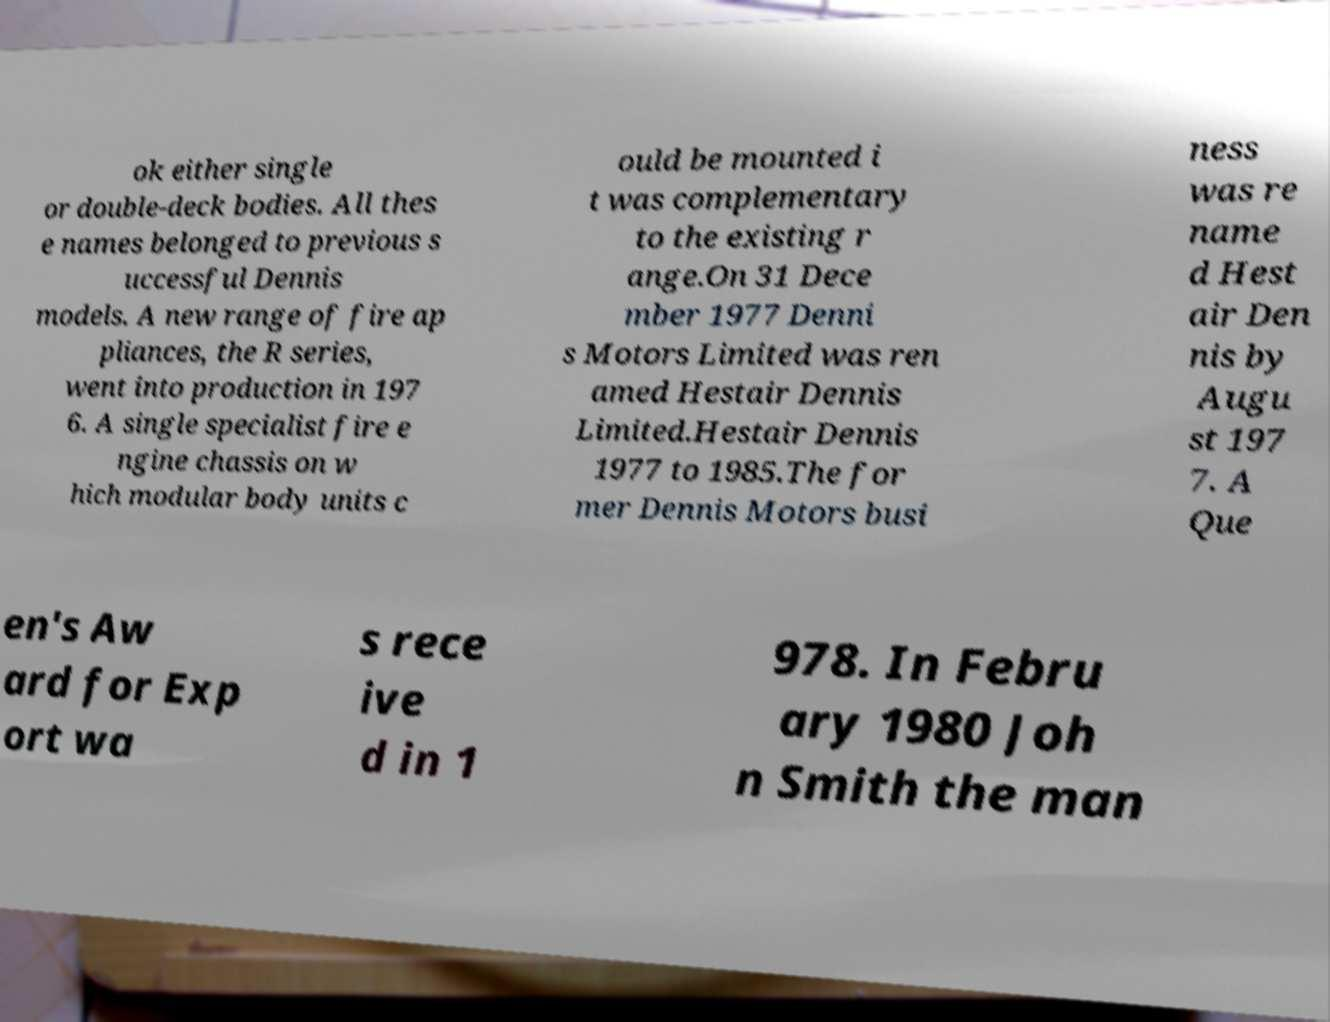Could you extract and type out the text from this image? ok either single or double-deck bodies. All thes e names belonged to previous s uccessful Dennis models. A new range of fire ap pliances, the R series, went into production in 197 6. A single specialist fire e ngine chassis on w hich modular body units c ould be mounted i t was complementary to the existing r ange.On 31 Dece mber 1977 Denni s Motors Limited was ren amed Hestair Dennis Limited.Hestair Dennis 1977 to 1985.The for mer Dennis Motors busi ness was re name d Hest air Den nis by Augu st 197 7. A Que en's Aw ard for Exp ort wa s rece ive d in 1 978. In Febru ary 1980 Joh n Smith the man 